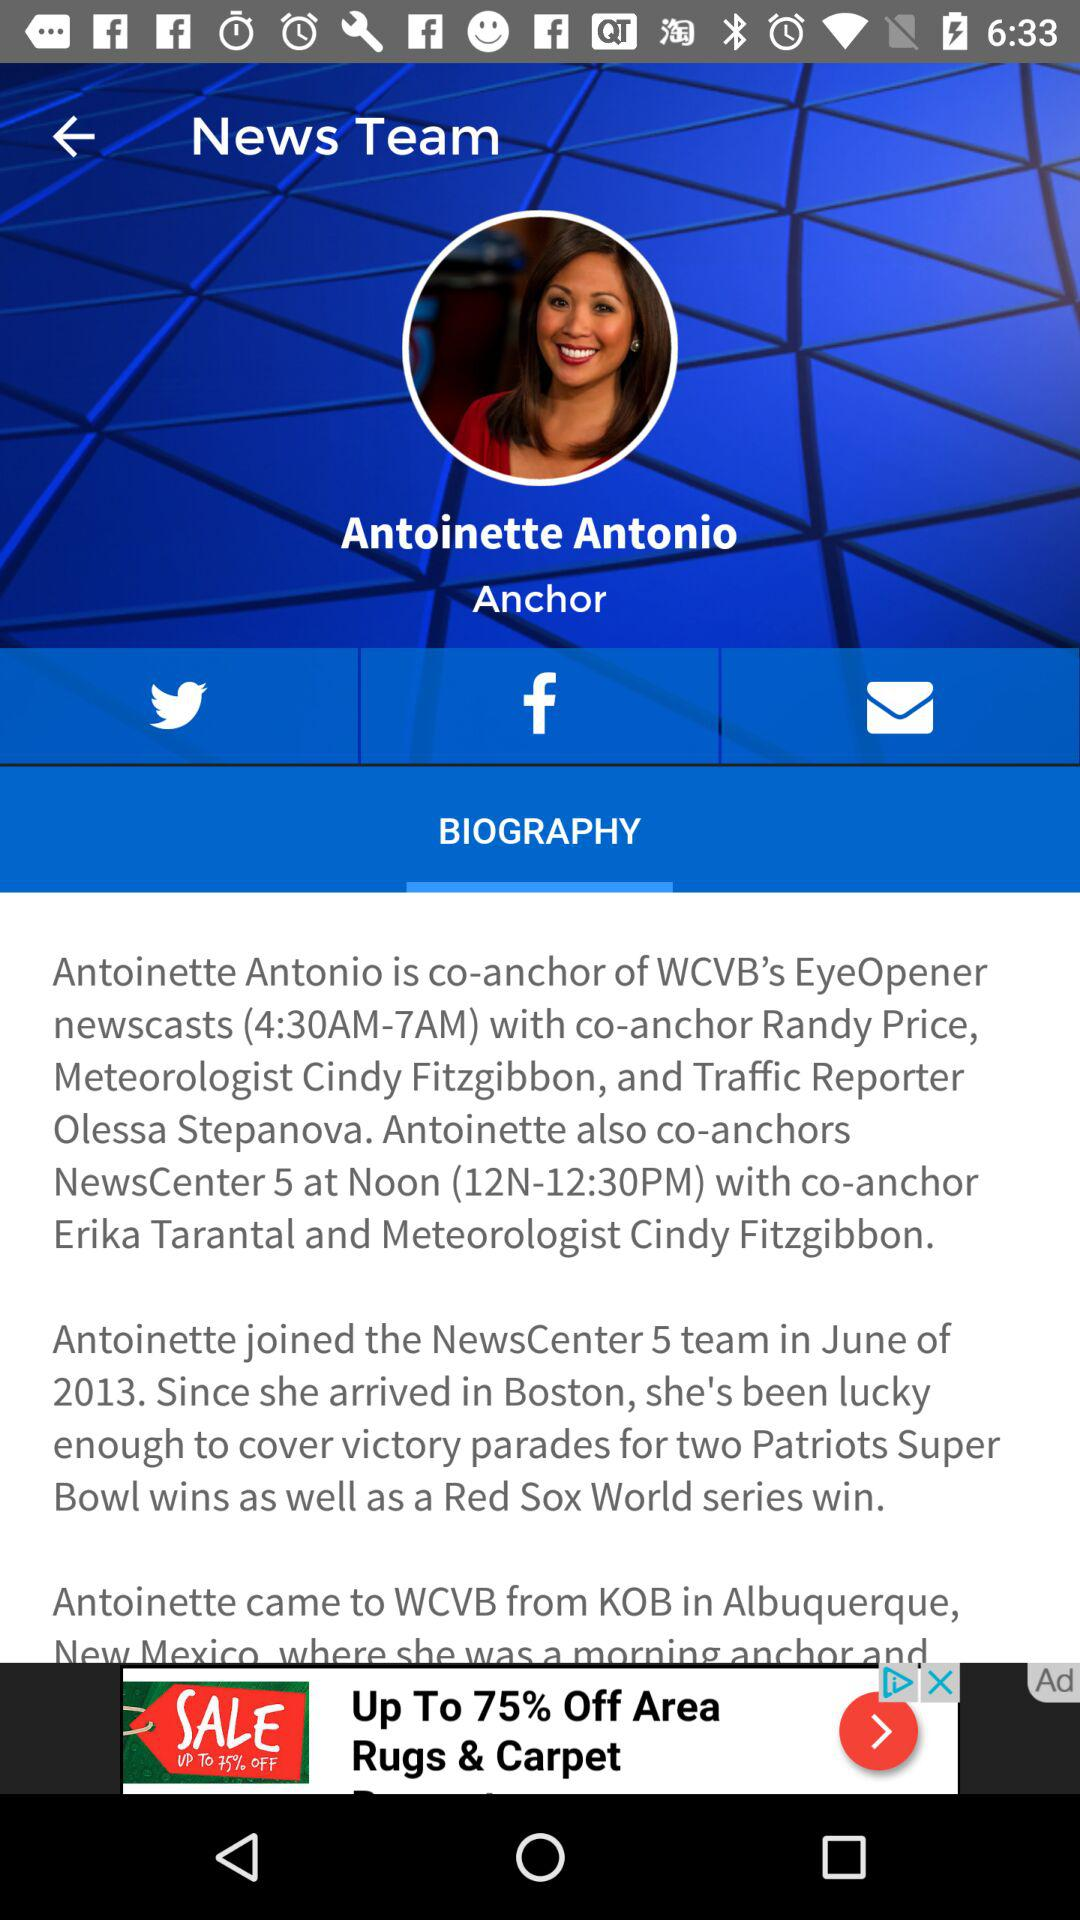Who is the anchor? The anchor is Antoinette Antonio. 